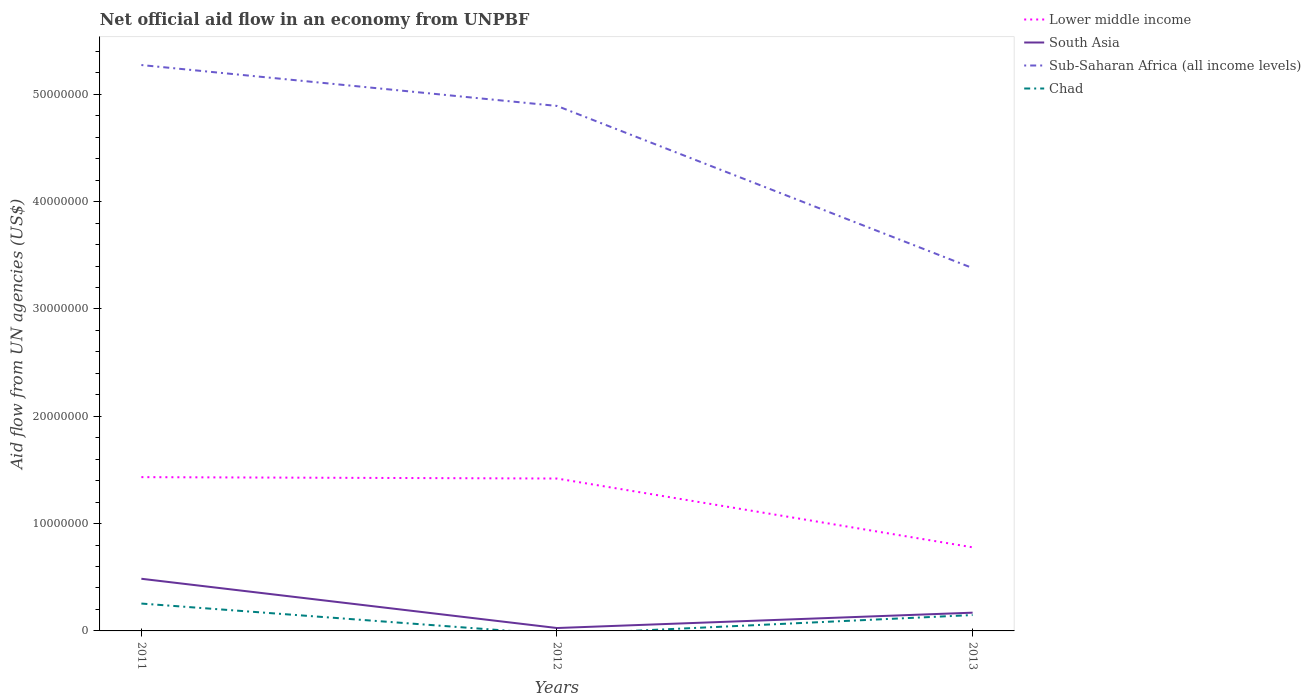How many different coloured lines are there?
Offer a very short reply. 4. Does the line corresponding to South Asia intersect with the line corresponding to Sub-Saharan Africa (all income levels)?
Your response must be concise. No. What is the total net official aid flow in Sub-Saharan Africa (all income levels) in the graph?
Ensure brevity in your answer.  3.81e+06. What is the difference between the highest and the second highest net official aid flow in Chad?
Give a very brief answer. 2.55e+06. How many lines are there?
Offer a terse response. 4. How many years are there in the graph?
Your answer should be compact. 3. What is the difference between two consecutive major ticks on the Y-axis?
Provide a short and direct response. 1.00e+07. Does the graph contain any zero values?
Give a very brief answer. Yes. Does the graph contain grids?
Ensure brevity in your answer.  No. Where does the legend appear in the graph?
Your response must be concise. Top right. How many legend labels are there?
Provide a succinct answer. 4. How are the legend labels stacked?
Offer a very short reply. Vertical. What is the title of the graph?
Your answer should be very brief. Net official aid flow in an economy from UNPBF. What is the label or title of the X-axis?
Provide a short and direct response. Years. What is the label or title of the Y-axis?
Make the answer very short. Aid flow from UN agencies (US$). What is the Aid flow from UN agencies (US$) of Lower middle income in 2011?
Keep it short and to the point. 1.43e+07. What is the Aid flow from UN agencies (US$) of South Asia in 2011?
Provide a succinct answer. 4.86e+06. What is the Aid flow from UN agencies (US$) in Sub-Saharan Africa (all income levels) in 2011?
Ensure brevity in your answer.  5.27e+07. What is the Aid flow from UN agencies (US$) in Chad in 2011?
Provide a short and direct response. 2.55e+06. What is the Aid flow from UN agencies (US$) of Lower middle income in 2012?
Your response must be concise. 1.42e+07. What is the Aid flow from UN agencies (US$) of South Asia in 2012?
Your answer should be very brief. 2.70e+05. What is the Aid flow from UN agencies (US$) in Sub-Saharan Africa (all income levels) in 2012?
Your answer should be compact. 4.89e+07. What is the Aid flow from UN agencies (US$) in Chad in 2012?
Offer a very short reply. 0. What is the Aid flow from UN agencies (US$) in Lower middle income in 2013?
Provide a succinct answer. 7.79e+06. What is the Aid flow from UN agencies (US$) in South Asia in 2013?
Provide a short and direct response. 1.70e+06. What is the Aid flow from UN agencies (US$) of Sub-Saharan Africa (all income levels) in 2013?
Your answer should be compact. 3.38e+07. What is the Aid flow from UN agencies (US$) of Chad in 2013?
Your answer should be very brief. 1.48e+06. Across all years, what is the maximum Aid flow from UN agencies (US$) in Lower middle income?
Your answer should be very brief. 1.43e+07. Across all years, what is the maximum Aid flow from UN agencies (US$) of South Asia?
Offer a very short reply. 4.86e+06. Across all years, what is the maximum Aid flow from UN agencies (US$) of Sub-Saharan Africa (all income levels)?
Your response must be concise. 5.27e+07. Across all years, what is the maximum Aid flow from UN agencies (US$) of Chad?
Your response must be concise. 2.55e+06. Across all years, what is the minimum Aid flow from UN agencies (US$) of Lower middle income?
Your answer should be compact. 7.79e+06. Across all years, what is the minimum Aid flow from UN agencies (US$) in Sub-Saharan Africa (all income levels)?
Offer a terse response. 3.38e+07. Across all years, what is the minimum Aid flow from UN agencies (US$) in Chad?
Provide a succinct answer. 0. What is the total Aid flow from UN agencies (US$) in Lower middle income in the graph?
Your answer should be very brief. 3.63e+07. What is the total Aid flow from UN agencies (US$) in South Asia in the graph?
Provide a succinct answer. 6.83e+06. What is the total Aid flow from UN agencies (US$) of Sub-Saharan Africa (all income levels) in the graph?
Give a very brief answer. 1.35e+08. What is the total Aid flow from UN agencies (US$) in Chad in the graph?
Make the answer very short. 4.03e+06. What is the difference between the Aid flow from UN agencies (US$) in South Asia in 2011 and that in 2012?
Offer a very short reply. 4.59e+06. What is the difference between the Aid flow from UN agencies (US$) in Sub-Saharan Africa (all income levels) in 2011 and that in 2012?
Ensure brevity in your answer.  3.81e+06. What is the difference between the Aid flow from UN agencies (US$) of Lower middle income in 2011 and that in 2013?
Provide a short and direct response. 6.54e+06. What is the difference between the Aid flow from UN agencies (US$) in South Asia in 2011 and that in 2013?
Your answer should be very brief. 3.16e+06. What is the difference between the Aid flow from UN agencies (US$) of Sub-Saharan Africa (all income levels) in 2011 and that in 2013?
Keep it short and to the point. 1.89e+07. What is the difference between the Aid flow from UN agencies (US$) of Chad in 2011 and that in 2013?
Provide a succinct answer. 1.07e+06. What is the difference between the Aid flow from UN agencies (US$) of Lower middle income in 2012 and that in 2013?
Your response must be concise. 6.41e+06. What is the difference between the Aid flow from UN agencies (US$) in South Asia in 2012 and that in 2013?
Your answer should be very brief. -1.43e+06. What is the difference between the Aid flow from UN agencies (US$) in Sub-Saharan Africa (all income levels) in 2012 and that in 2013?
Offer a terse response. 1.51e+07. What is the difference between the Aid flow from UN agencies (US$) in Lower middle income in 2011 and the Aid flow from UN agencies (US$) in South Asia in 2012?
Provide a succinct answer. 1.41e+07. What is the difference between the Aid flow from UN agencies (US$) in Lower middle income in 2011 and the Aid flow from UN agencies (US$) in Sub-Saharan Africa (all income levels) in 2012?
Make the answer very short. -3.46e+07. What is the difference between the Aid flow from UN agencies (US$) of South Asia in 2011 and the Aid flow from UN agencies (US$) of Sub-Saharan Africa (all income levels) in 2012?
Your response must be concise. -4.41e+07. What is the difference between the Aid flow from UN agencies (US$) in Lower middle income in 2011 and the Aid flow from UN agencies (US$) in South Asia in 2013?
Keep it short and to the point. 1.26e+07. What is the difference between the Aid flow from UN agencies (US$) of Lower middle income in 2011 and the Aid flow from UN agencies (US$) of Sub-Saharan Africa (all income levels) in 2013?
Ensure brevity in your answer.  -1.95e+07. What is the difference between the Aid flow from UN agencies (US$) in Lower middle income in 2011 and the Aid flow from UN agencies (US$) in Chad in 2013?
Offer a very short reply. 1.28e+07. What is the difference between the Aid flow from UN agencies (US$) in South Asia in 2011 and the Aid flow from UN agencies (US$) in Sub-Saharan Africa (all income levels) in 2013?
Your answer should be very brief. -2.90e+07. What is the difference between the Aid flow from UN agencies (US$) of South Asia in 2011 and the Aid flow from UN agencies (US$) of Chad in 2013?
Provide a succinct answer. 3.38e+06. What is the difference between the Aid flow from UN agencies (US$) of Sub-Saharan Africa (all income levels) in 2011 and the Aid flow from UN agencies (US$) of Chad in 2013?
Offer a terse response. 5.12e+07. What is the difference between the Aid flow from UN agencies (US$) of Lower middle income in 2012 and the Aid flow from UN agencies (US$) of South Asia in 2013?
Keep it short and to the point. 1.25e+07. What is the difference between the Aid flow from UN agencies (US$) in Lower middle income in 2012 and the Aid flow from UN agencies (US$) in Sub-Saharan Africa (all income levels) in 2013?
Your response must be concise. -1.96e+07. What is the difference between the Aid flow from UN agencies (US$) in Lower middle income in 2012 and the Aid flow from UN agencies (US$) in Chad in 2013?
Your answer should be compact. 1.27e+07. What is the difference between the Aid flow from UN agencies (US$) in South Asia in 2012 and the Aid flow from UN agencies (US$) in Sub-Saharan Africa (all income levels) in 2013?
Offer a terse response. -3.35e+07. What is the difference between the Aid flow from UN agencies (US$) of South Asia in 2012 and the Aid flow from UN agencies (US$) of Chad in 2013?
Provide a succinct answer. -1.21e+06. What is the difference between the Aid flow from UN agencies (US$) of Sub-Saharan Africa (all income levels) in 2012 and the Aid flow from UN agencies (US$) of Chad in 2013?
Provide a succinct answer. 4.74e+07. What is the average Aid flow from UN agencies (US$) of Lower middle income per year?
Give a very brief answer. 1.21e+07. What is the average Aid flow from UN agencies (US$) of South Asia per year?
Your answer should be very brief. 2.28e+06. What is the average Aid flow from UN agencies (US$) of Sub-Saharan Africa (all income levels) per year?
Offer a very short reply. 4.52e+07. What is the average Aid flow from UN agencies (US$) in Chad per year?
Offer a terse response. 1.34e+06. In the year 2011, what is the difference between the Aid flow from UN agencies (US$) of Lower middle income and Aid flow from UN agencies (US$) of South Asia?
Your response must be concise. 9.47e+06. In the year 2011, what is the difference between the Aid flow from UN agencies (US$) of Lower middle income and Aid flow from UN agencies (US$) of Sub-Saharan Africa (all income levels)?
Your answer should be very brief. -3.84e+07. In the year 2011, what is the difference between the Aid flow from UN agencies (US$) of Lower middle income and Aid flow from UN agencies (US$) of Chad?
Ensure brevity in your answer.  1.18e+07. In the year 2011, what is the difference between the Aid flow from UN agencies (US$) in South Asia and Aid flow from UN agencies (US$) in Sub-Saharan Africa (all income levels)?
Your response must be concise. -4.79e+07. In the year 2011, what is the difference between the Aid flow from UN agencies (US$) of South Asia and Aid flow from UN agencies (US$) of Chad?
Give a very brief answer. 2.31e+06. In the year 2011, what is the difference between the Aid flow from UN agencies (US$) in Sub-Saharan Africa (all income levels) and Aid flow from UN agencies (US$) in Chad?
Provide a succinct answer. 5.02e+07. In the year 2012, what is the difference between the Aid flow from UN agencies (US$) of Lower middle income and Aid flow from UN agencies (US$) of South Asia?
Your answer should be very brief. 1.39e+07. In the year 2012, what is the difference between the Aid flow from UN agencies (US$) in Lower middle income and Aid flow from UN agencies (US$) in Sub-Saharan Africa (all income levels)?
Offer a terse response. -3.47e+07. In the year 2012, what is the difference between the Aid flow from UN agencies (US$) of South Asia and Aid flow from UN agencies (US$) of Sub-Saharan Africa (all income levels)?
Provide a succinct answer. -4.86e+07. In the year 2013, what is the difference between the Aid flow from UN agencies (US$) of Lower middle income and Aid flow from UN agencies (US$) of South Asia?
Give a very brief answer. 6.09e+06. In the year 2013, what is the difference between the Aid flow from UN agencies (US$) of Lower middle income and Aid flow from UN agencies (US$) of Sub-Saharan Africa (all income levels)?
Provide a succinct answer. -2.60e+07. In the year 2013, what is the difference between the Aid flow from UN agencies (US$) of Lower middle income and Aid flow from UN agencies (US$) of Chad?
Give a very brief answer. 6.31e+06. In the year 2013, what is the difference between the Aid flow from UN agencies (US$) of South Asia and Aid flow from UN agencies (US$) of Sub-Saharan Africa (all income levels)?
Provide a succinct answer. -3.21e+07. In the year 2013, what is the difference between the Aid flow from UN agencies (US$) of Sub-Saharan Africa (all income levels) and Aid flow from UN agencies (US$) of Chad?
Your response must be concise. 3.23e+07. What is the ratio of the Aid flow from UN agencies (US$) of Lower middle income in 2011 to that in 2012?
Ensure brevity in your answer.  1.01. What is the ratio of the Aid flow from UN agencies (US$) of Sub-Saharan Africa (all income levels) in 2011 to that in 2012?
Your answer should be very brief. 1.08. What is the ratio of the Aid flow from UN agencies (US$) of Lower middle income in 2011 to that in 2013?
Give a very brief answer. 1.84. What is the ratio of the Aid flow from UN agencies (US$) of South Asia in 2011 to that in 2013?
Your response must be concise. 2.86. What is the ratio of the Aid flow from UN agencies (US$) of Sub-Saharan Africa (all income levels) in 2011 to that in 2013?
Your answer should be compact. 1.56. What is the ratio of the Aid flow from UN agencies (US$) in Chad in 2011 to that in 2013?
Keep it short and to the point. 1.72. What is the ratio of the Aid flow from UN agencies (US$) of Lower middle income in 2012 to that in 2013?
Your response must be concise. 1.82. What is the ratio of the Aid flow from UN agencies (US$) in South Asia in 2012 to that in 2013?
Offer a terse response. 0.16. What is the ratio of the Aid flow from UN agencies (US$) of Sub-Saharan Africa (all income levels) in 2012 to that in 2013?
Your response must be concise. 1.45. What is the difference between the highest and the second highest Aid flow from UN agencies (US$) of South Asia?
Offer a terse response. 3.16e+06. What is the difference between the highest and the second highest Aid flow from UN agencies (US$) of Sub-Saharan Africa (all income levels)?
Offer a very short reply. 3.81e+06. What is the difference between the highest and the lowest Aid flow from UN agencies (US$) in Lower middle income?
Keep it short and to the point. 6.54e+06. What is the difference between the highest and the lowest Aid flow from UN agencies (US$) in South Asia?
Offer a very short reply. 4.59e+06. What is the difference between the highest and the lowest Aid flow from UN agencies (US$) of Sub-Saharan Africa (all income levels)?
Your answer should be compact. 1.89e+07. What is the difference between the highest and the lowest Aid flow from UN agencies (US$) of Chad?
Provide a short and direct response. 2.55e+06. 